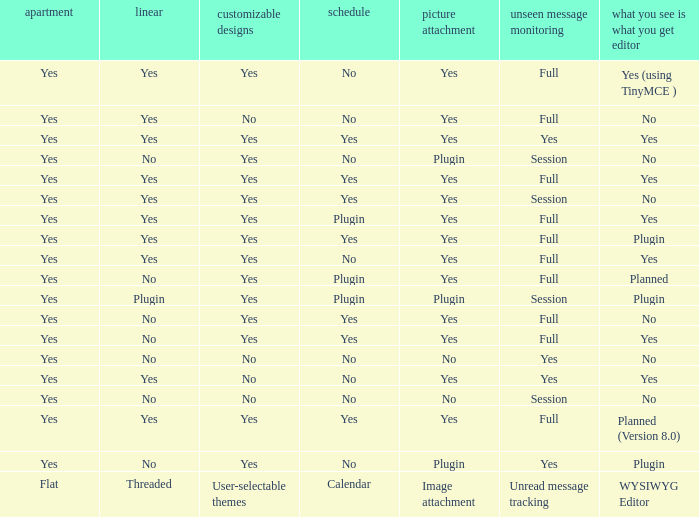Which Calendar has a WYSIWYG Editor of no, and an Unread message tracking of session, and an Image attachment of no? No. 